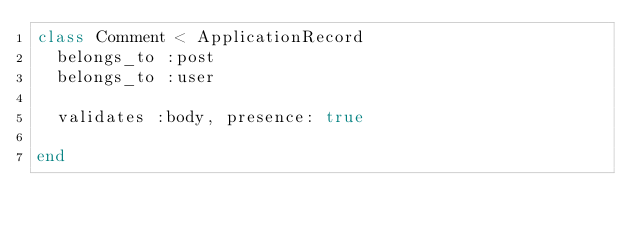Convert code to text. <code><loc_0><loc_0><loc_500><loc_500><_Ruby_>class Comment < ApplicationRecord
  belongs_to :post
  belongs_to :user

  validates :body, presence: true
  
end
</code> 